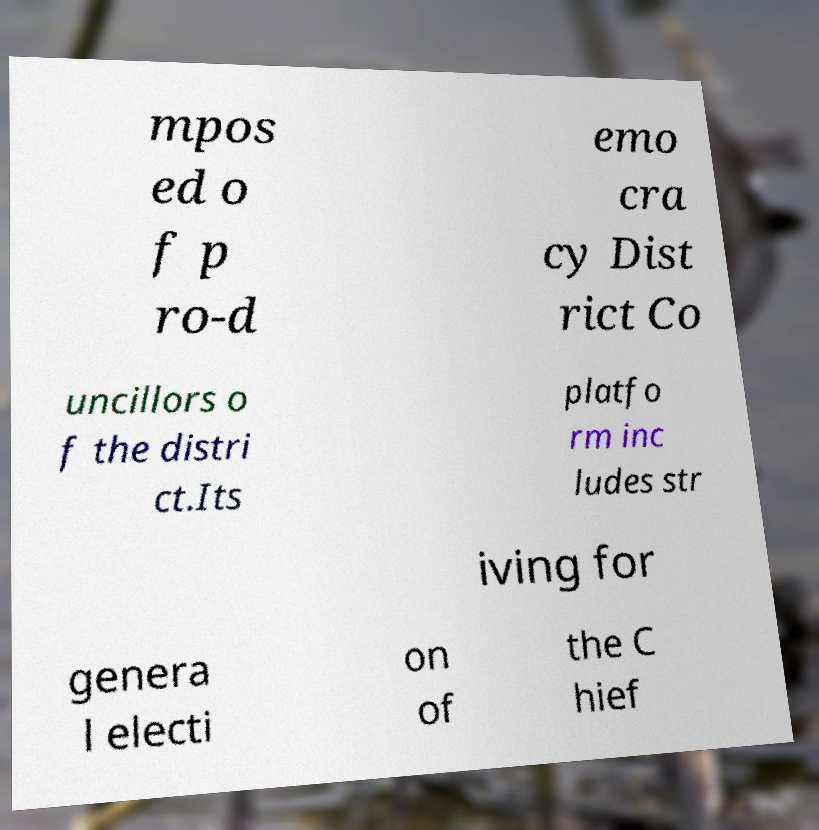Can you read and provide the text displayed in the image?This photo seems to have some interesting text. Can you extract and type it out for me? mpos ed o f p ro-d emo cra cy Dist rict Co uncillors o f the distri ct.Its platfo rm inc ludes str iving for genera l electi on of the C hief 